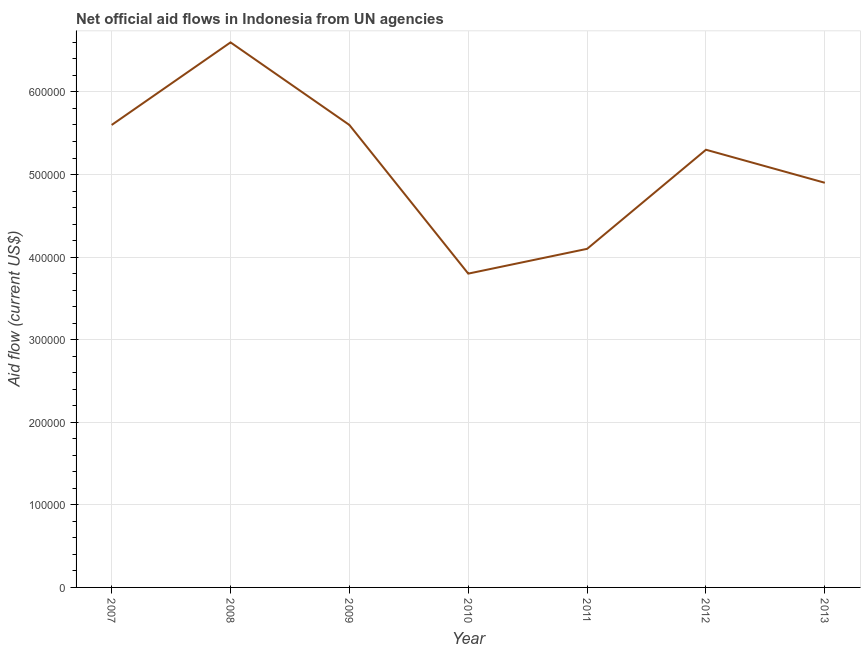What is the net official flows from un agencies in 2010?
Offer a terse response. 3.80e+05. Across all years, what is the maximum net official flows from un agencies?
Give a very brief answer. 6.60e+05. Across all years, what is the minimum net official flows from un agencies?
Keep it short and to the point. 3.80e+05. In which year was the net official flows from un agencies minimum?
Your answer should be compact. 2010. What is the sum of the net official flows from un agencies?
Ensure brevity in your answer.  3.59e+06. What is the difference between the net official flows from un agencies in 2008 and 2012?
Your answer should be compact. 1.30e+05. What is the average net official flows from un agencies per year?
Provide a short and direct response. 5.13e+05. What is the median net official flows from un agencies?
Provide a succinct answer. 5.30e+05. Do a majority of the years between 2010 and 2008 (inclusive) have net official flows from un agencies greater than 320000 US$?
Your answer should be very brief. No. What is the ratio of the net official flows from un agencies in 2011 to that in 2012?
Keep it short and to the point. 0.77. Is the difference between the net official flows from un agencies in 2011 and 2013 greater than the difference between any two years?
Offer a terse response. No. Is the sum of the net official flows from un agencies in 2009 and 2011 greater than the maximum net official flows from un agencies across all years?
Make the answer very short. Yes. What is the difference between the highest and the lowest net official flows from un agencies?
Your response must be concise. 2.80e+05. In how many years, is the net official flows from un agencies greater than the average net official flows from un agencies taken over all years?
Your response must be concise. 4. How many lines are there?
Your response must be concise. 1. How many years are there in the graph?
Keep it short and to the point. 7. What is the difference between two consecutive major ticks on the Y-axis?
Give a very brief answer. 1.00e+05. Are the values on the major ticks of Y-axis written in scientific E-notation?
Your response must be concise. No. Does the graph contain grids?
Your answer should be compact. Yes. What is the title of the graph?
Your answer should be very brief. Net official aid flows in Indonesia from UN agencies. What is the Aid flow (current US$) of 2007?
Offer a terse response. 5.60e+05. What is the Aid flow (current US$) in 2008?
Your response must be concise. 6.60e+05. What is the Aid flow (current US$) in 2009?
Provide a succinct answer. 5.60e+05. What is the Aid flow (current US$) of 2012?
Your answer should be compact. 5.30e+05. What is the Aid flow (current US$) of 2013?
Provide a short and direct response. 4.90e+05. What is the difference between the Aid flow (current US$) in 2007 and 2011?
Provide a succinct answer. 1.50e+05. What is the difference between the Aid flow (current US$) in 2007 and 2013?
Ensure brevity in your answer.  7.00e+04. What is the difference between the Aid flow (current US$) in 2008 and 2009?
Your answer should be compact. 1.00e+05. What is the difference between the Aid flow (current US$) in 2008 and 2011?
Offer a terse response. 2.50e+05. What is the difference between the Aid flow (current US$) in 2008 and 2012?
Your answer should be very brief. 1.30e+05. What is the difference between the Aid flow (current US$) in 2009 and 2010?
Make the answer very short. 1.80e+05. What is the difference between the Aid flow (current US$) in 2009 and 2011?
Provide a short and direct response. 1.50e+05. What is the ratio of the Aid flow (current US$) in 2007 to that in 2008?
Give a very brief answer. 0.85. What is the ratio of the Aid flow (current US$) in 2007 to that in 2010?
Provide a succinct answer. 1.47. What is the ratio of the Aid flow (current US$) in 2007 to that in 2011?
Make the answer very short. 1.37. What is the ratio of the Aid flow (current US$) in 2007 to that in 2012?
Your answer should be compact. 1.06. What is the ratio of the Aid flow (current US$) in 2007 to that in 2013?
Provide a short and direct response. 1.14. What is the ratio of the Aid flow (current US$) in 2008 to that in 2009?
Provide a short and direct response. 1.18. What is the ratio of the Aid flow (current US$) in 2008 to that in 2010?
Make the answer very short. 1.74. What is the ratio of the Aid flow (current US$) in 2008 to that in 2011?
Keep it short and to the point. 1.61. What is the ratio of the Aid flow (current US$) in 2008 to that in 2012?
Your answer should be very brief. 1.25. What is the ratio of the Aid flow (current US$) in 2008 to that in 2013?
Provide a short and direct response. 1.35. What is the ratio of the Aid flow (current US$) in 2009 to that in 2010?
Keep it short and to the point. 1.47. What is the ratio of the Aid flow (current US$) in 2009 to that in 2011?
Ensure brevity in your answer.  1.37. What is the ratio of the Aid flow (current US$) in 2009 to that in 2012?
Offer a terse response. 1.06. What is the ratio of the Aid flow (current US$) in 2009 to that in 2013?
Provide a succinct answer. 1.14. What is the ratio of the Aid flow (current US$) in 2010 to that in 2011?
Offer a very short reply. 0.93. What is the ratio of the Aid flow (current US$) in 2010 to that in 2012?
Ensure brevity in your answer.  0.72. What is the ratio of the Aid flow (current US$) in 2010 to that in 2013?
Provide a short and direct response. 0.78. What is the ratio of the Aid flow (current US$) in 2011 to that in 2012?
Provide a succinct answer. 0.77. What is the ratio of the Aid flow (current US$) in 2011 to that in 2013?
Provide a short and direct response. 0.84. What is the ratio of the Aid flow (current US$) in 2012 to that in 2013?
Offer a terse response. 1.08. 